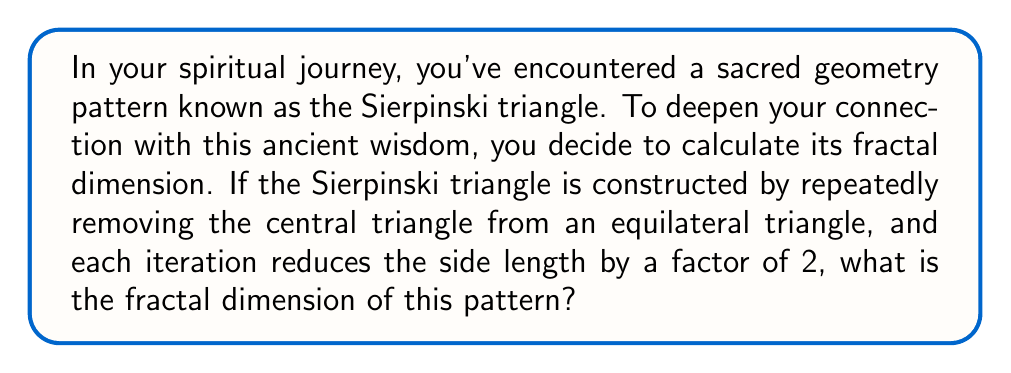Can you answer this question? To determine the fractal dimension of the Sierpinski triangle, we'll use the concept of self-similarity and the box-counting method. This aligns with the grandmother's wisdom of understanding patterns in nature.

1. Let's define the fractal dimension $D$ using the formula:

   $$N = r^D$$

   where $N$ is the number of self-similar pieces, and $r$ is the reduction factor.

2. For the Sierpinski triangle:
   - Each iteration creates 3 self-similar pieces ($N = 3$)
   - The reduction factor is 1/2 ($r = 1/2$)

3. Substituting these values into the equation:

   $$3 = (1/2)^D$$

4. Taking the logarithm of both sides:

   $$\log 3 = D \log(1/2)$$
   $$\log 3 = -D \log 2$$

5. Solving for $D$:

   $$D = \frac{\log 3}{log 2} \approx 1.5849625$$

This fractal dimension between 1 and 2 reflects the Sierpinski triangle's nature as a shape that's more complex than a line (dimension 1) but doesn't quite fill a plane (dimension 2).

[asy]
import geometry;

void sierpinski(pair A, pair B, pair C, int n) {
  if(n == 0) {
    fill(A--B--C--cycle, gray(0.8));
  } else {
    pair AB = (A+B)/2, BC = (B+C)/2, CA = (C+A)/2;
    sierpinski(A, AB, CA, n-1);
    sierpinski(B, BC, AB, n-1);
    sierpinski(C, CA, BC, n-1);
  }
}

size(200);
pair A = (0,0), B = (1,0), C = (0.5, 0.866);
sierpinski(A, B, C, 5);
draw(A--B--C--cycle);
[/asy]
Answer: The fractal dimension of the Sierpinski triangle is $\frac{\log 3}{\log 2} \approx 1.5849625$. 